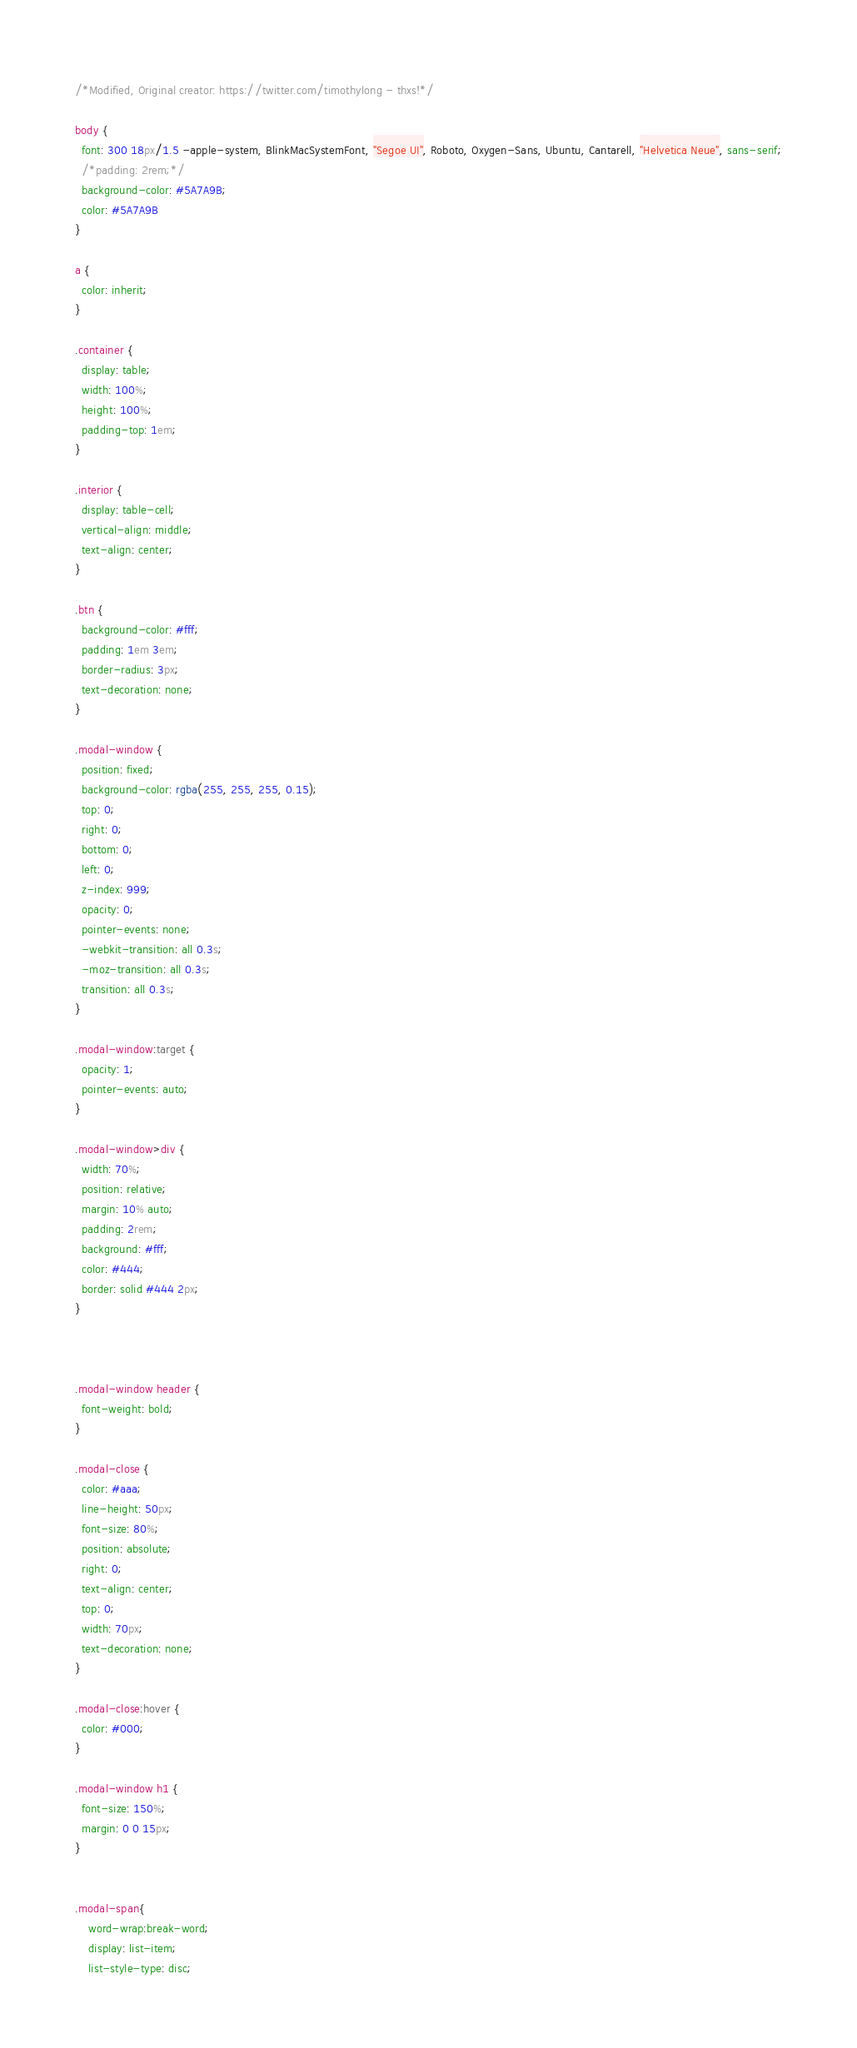<code> <loc_0><loc_0><loc_500><loc_500><_CSS_>/*Modified, Original creator: https://twitter.com/timothylong - thxs!*/

body {
  font: 300 18px/1.5 -apple-system, BlinkMacSystemFont, "Segoe UI", Roboto, Oxygen-Sans, Ubuntu, Cantarell, "Helvetica Neue", sans-serif;
  /*padding: 2rem;*/
  background-color: #5A7A9B;
  color: #5A7A9B
}

a {
  color: inherit;
}

.container {
  display: table;
  width: 100%;
  height: 100%;
  padding-top: 1em;
}

.interior {
  display: table-cell;
  vertical-align: middle;
  text-align: center;
}

.btn {
  background-color: #fff;
  padding: 1em 3em;
  border-radius: 3px;
  text-decoration: none;
}

.modal-window {
  position: fixed;
  background-color: rgba(255, 255, 255, 0.15);
  top: 0;
  right: 0;
  bottom: 0;
  left: 0;
  z-index: 999;
  opacity: 0;
  pointer-events: none;
  -webkit-transition: all 0.3s;
  -moz-transition: all 0.3s;
  transition: all 0.3s;
}

.modal-window:target {
  opacity: 1;
  pointer-events: auto;
}

.modal-window>div {
  width: 70%;
  position: relative;
  margin: 10% auto;
  padding: 2rem;
  background: #fff;
  color: #444;
  border: solid #444 2px;
}



.modal-window header {
  font-weight: bold;
}

.modal-close {
  color: #aaa;
  line-height: 50px;
  font-size: 80%;
  position: absolute;
  right: 0;
  text-align: center;
  top: 0;
  width: 70px;
  text-decoration: none;
}

.modal-close:hover {
  color: #000;
}

.modal-window h1 {
  font-size: 150%;
  margin: 0 0 15px;
}


.modal-span{
	word-wrap:break-word;
	display: list-item;
	list-style-type: disc;</code> 